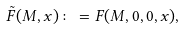<formula> <loc_0><loc_0><loc_500><loc_500>\tilde { F } ( M , x ) \colon = F ( M , 0 , 0 , x ) ,</formula> 